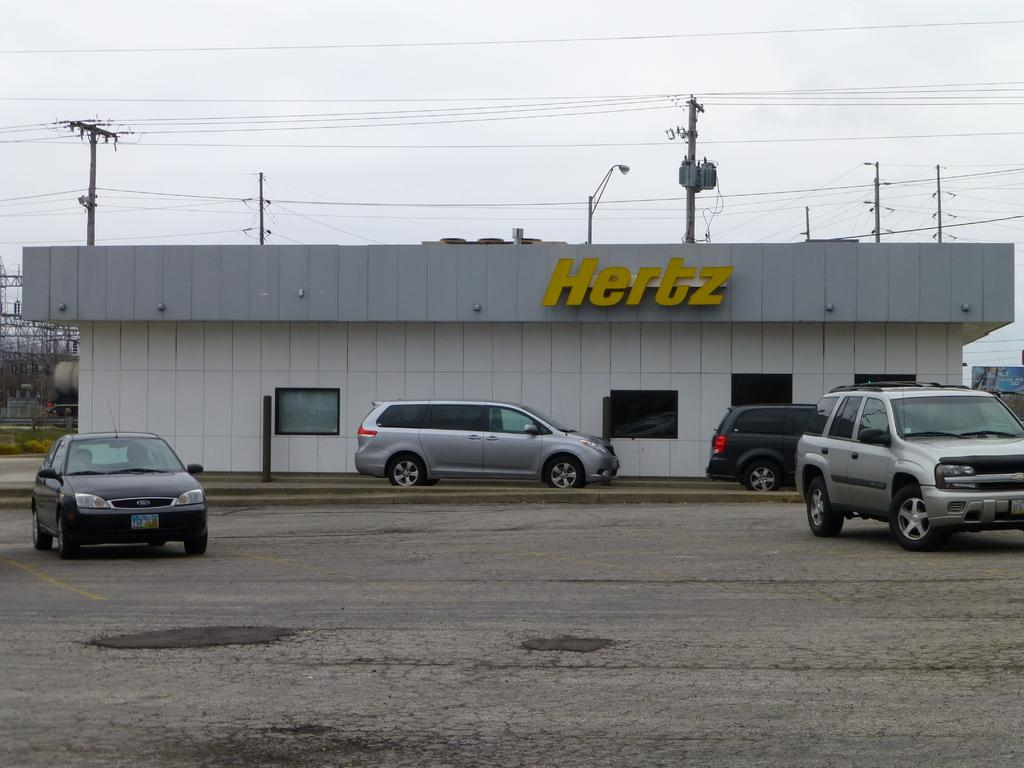What type of establishment is shown in the image? There is a store in the image. What can be seen in the middle of the image? There are cars and poles in the middle of the image. What is visible at the top of the image? The sky is visible at the top of the image. How many fingers can be seen on the store's hand in the image? There are no hands or fingers present on the store in the image. Is there a sink visible in the image? There is no sink present in the image. 